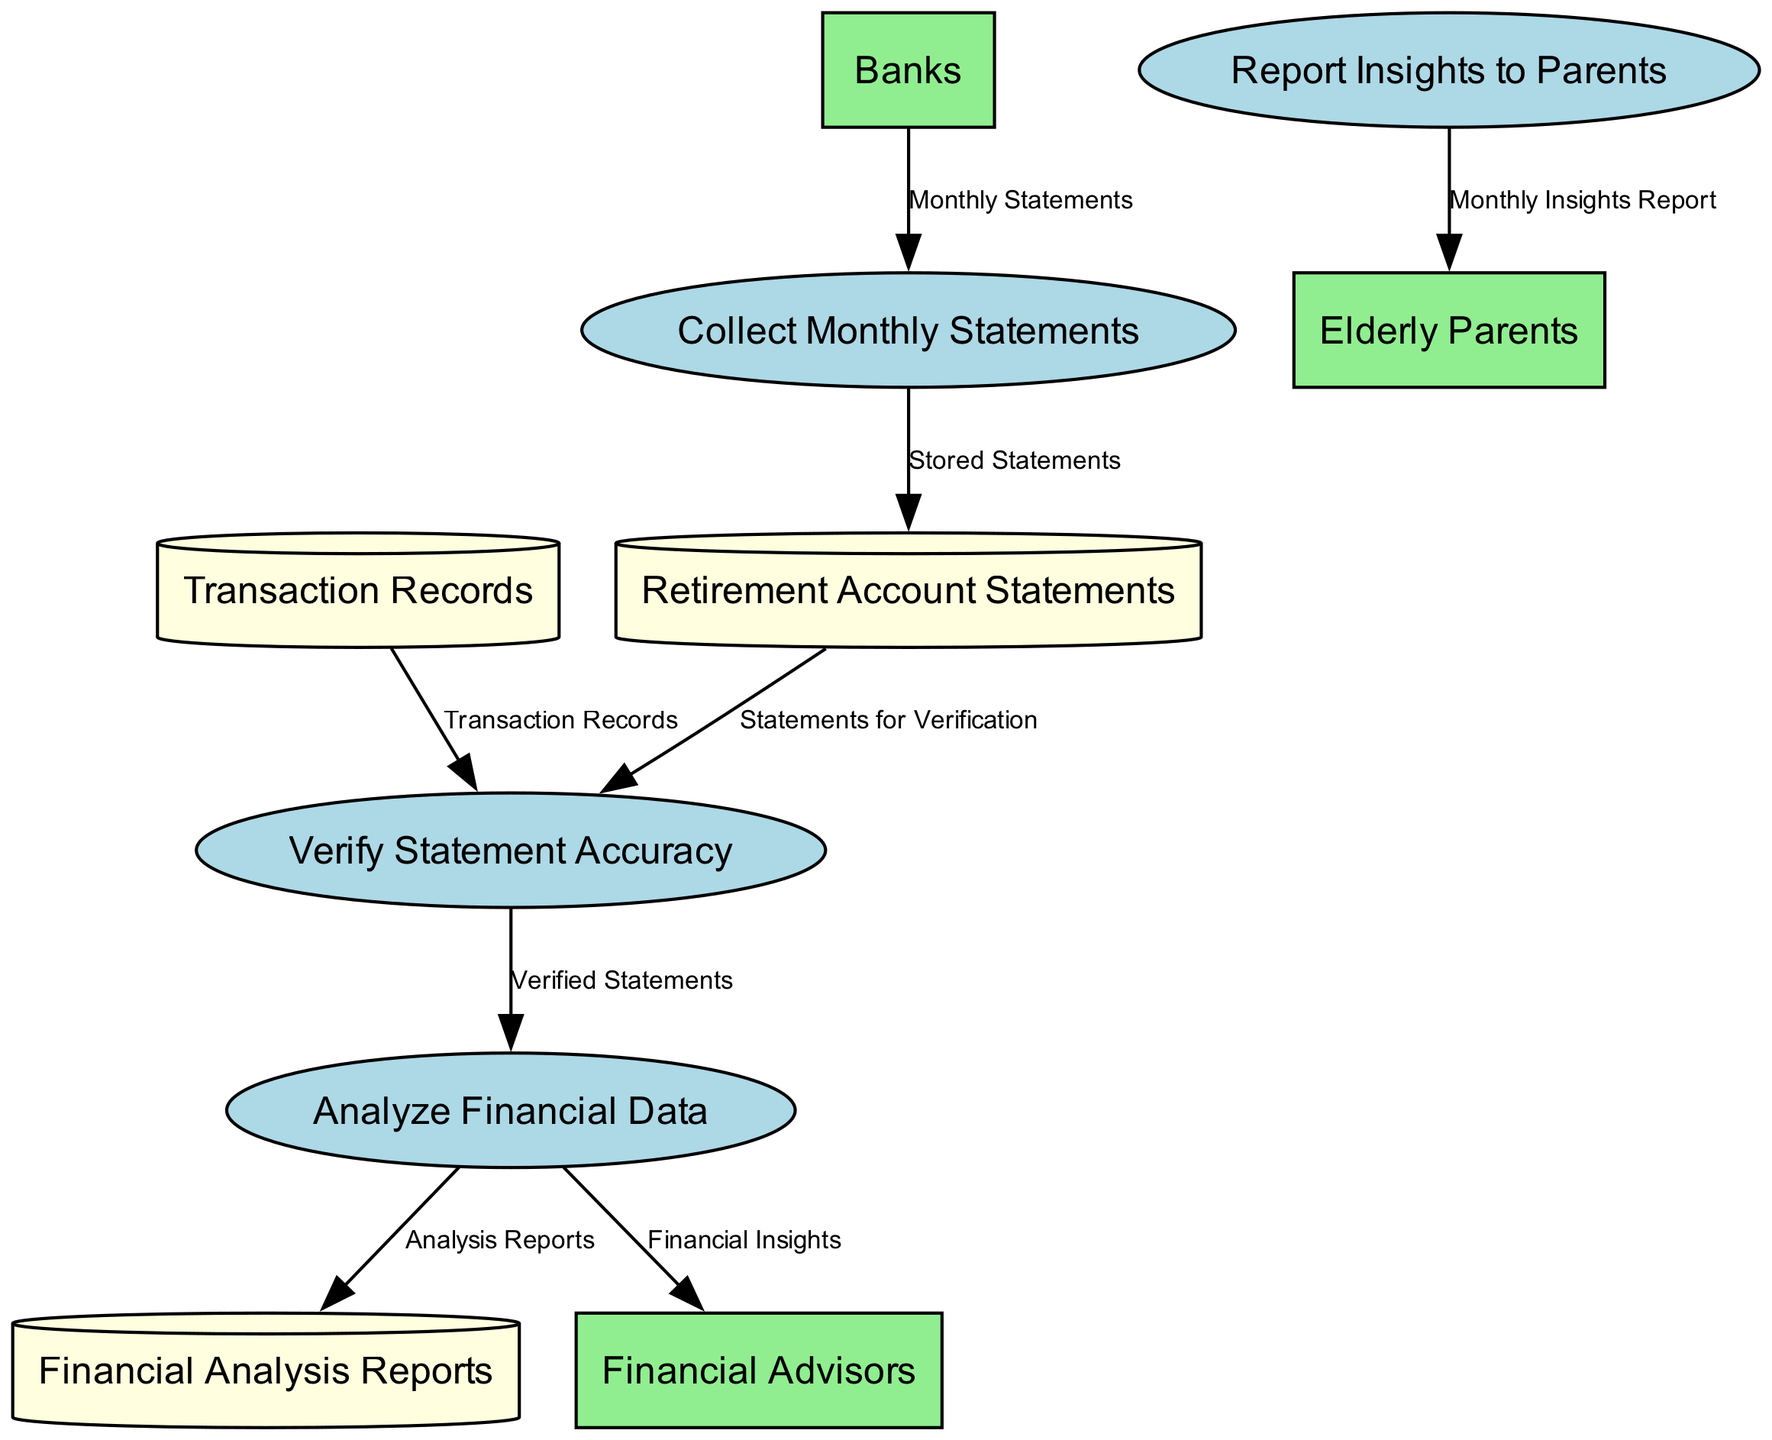What is the name of the first process? The first process in the diagram is labeled "P1", which corresponds to "Collect Monthly Statements". This is indicated by the order of the processes listed in the data provided.
Answer: Collect Monthly Statements How many data stores are present in the diagram? The data stores in the diagram are listed under "data_stores". There are three distinct entries in this section: "Retirement Account Statements", "Transaction Records", and "Financial Analysis Reports". Therefore, there are three data stores.
Answer: 3 What type of entity is "E1"? "E1" refers to "Banks", which is categorized as an external entity that provides monthly retirement account statements to the process "Collect Monthly Statements". The classification is shown in the "external_entities" section of the data.
Answer: External entity Which process sends insights to financial advisors? The process "P3" named "Analyze Financial Data" transmits "Financial Insights" to "E2", which represents financial advisors. This is deduced from the flow indicated in data_flows.
Answer: P3 What does the "D2" data store contain? The store labeled "D2" contains "Transaction Records". This is clearly defined in the description of the data stores provided in the data section.
Answer: Transaction Records What is the relationship between "P2" and "D1"? "P2" (Verify Statement Accuracy) receives "Statements for Verification" from "D1" (Retirement Account Statements). The data flow labeled "F3" illustrates this connection and what data is being exchanged.
Answer: F3 How many external entities interact with the processes? The external entities listed are "Banks", "Financial Advisors", and "Elderly Parents", which totals to three. This count can be confirmed by reviewing the "external_entities" section.
Answer: 3 What is the output of process "P4"? The output of process "P4" (Report Insights to Parents) is labeled "Monthly Insights Report". This is indicated in the data flow where information is communicated to "E3", which represents the elderly parents.
Answer: Monthly Insights Report Which process is responsible for analyzing the financial data? The process responsible for analyzing financial data is "P3", which is explicitly named "Analyze Financial Data". This information is stated in the processes provided in the data.
Answer: P3 